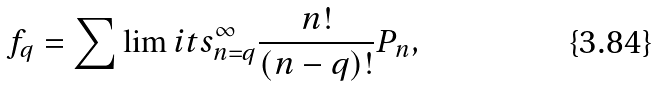<formula> <loc_0><loc_0><loc_500><loc_500>f _ { q } = \sum \lim i t s _ { n = q } ^ { \infty } \frac { n ! } { ( n - q ) ! } P _ { n } ,</formula> 